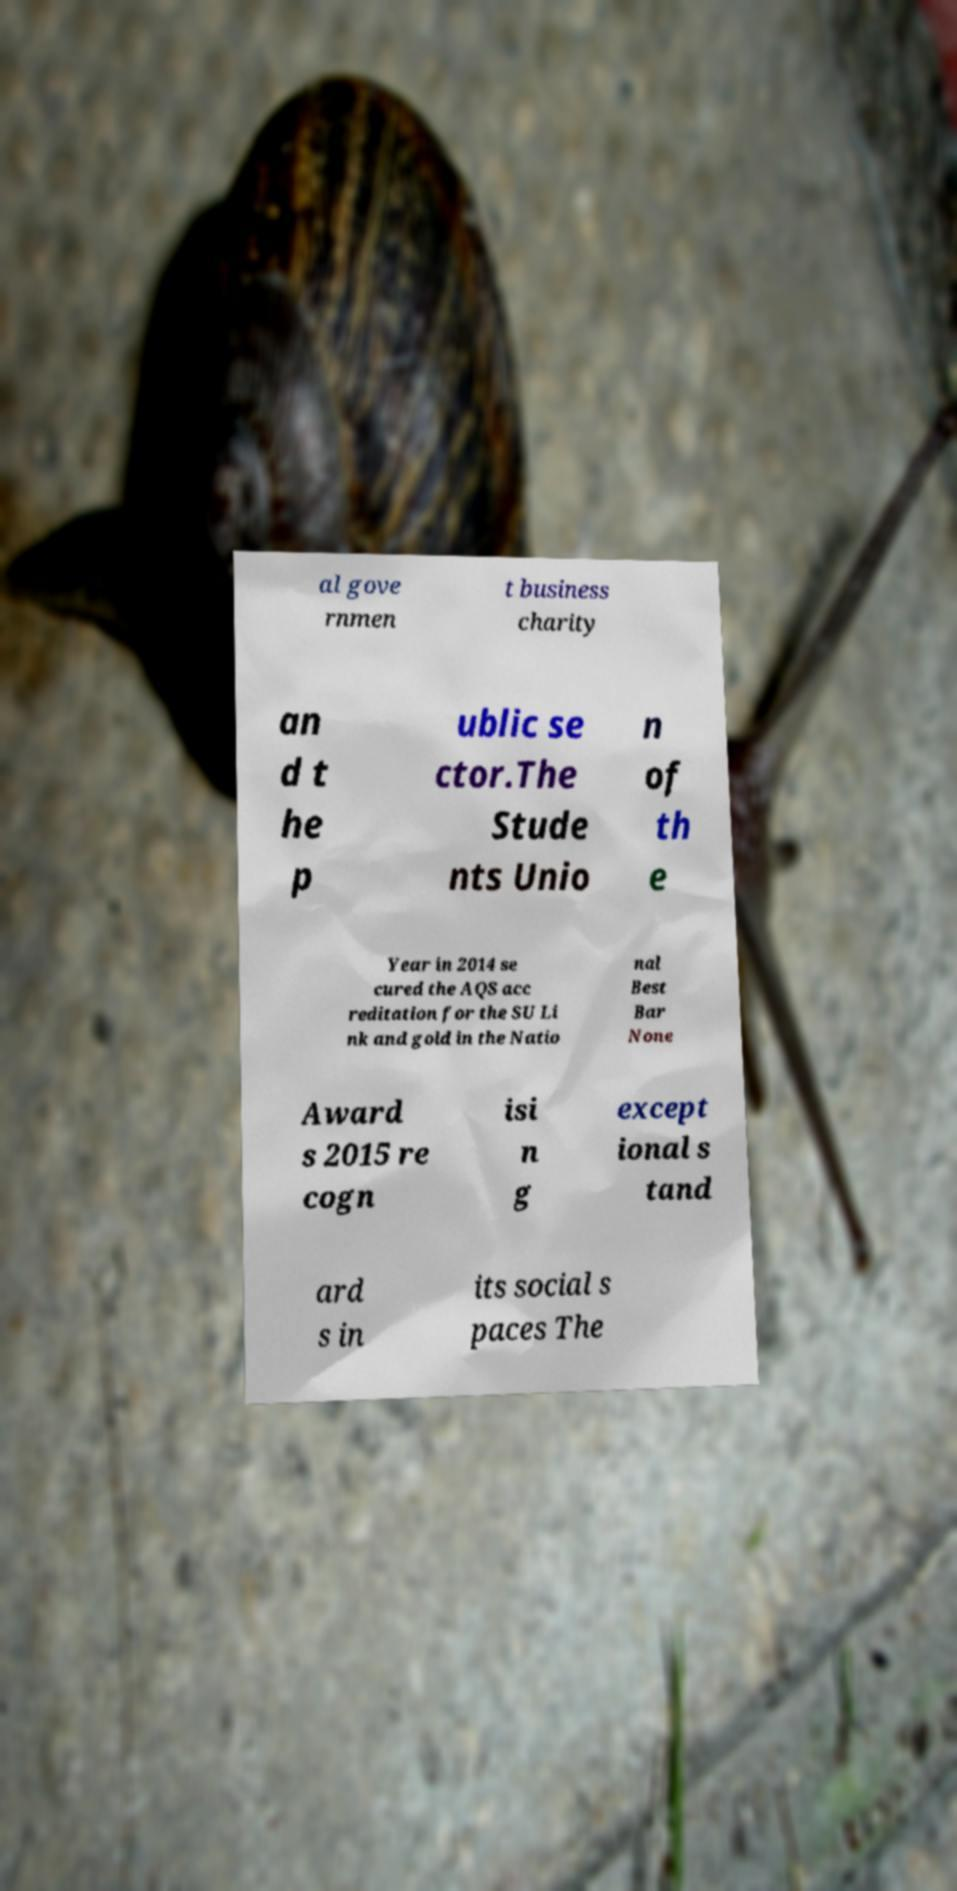Can you read and provide the text displayed in the image?This photo seems to have some interesting text. Can you extract and type it out for me? al gove rnmen t business charity an d t he p ublic se ctor.The Stude nts Unio n of th e Year in 2014 se cured the AQS acc reditation for the SU Li nk and gold in the Natio nal Best Bar None Award s 2015 re cogn isi n g except ional s tand ard s in its social s paces The 